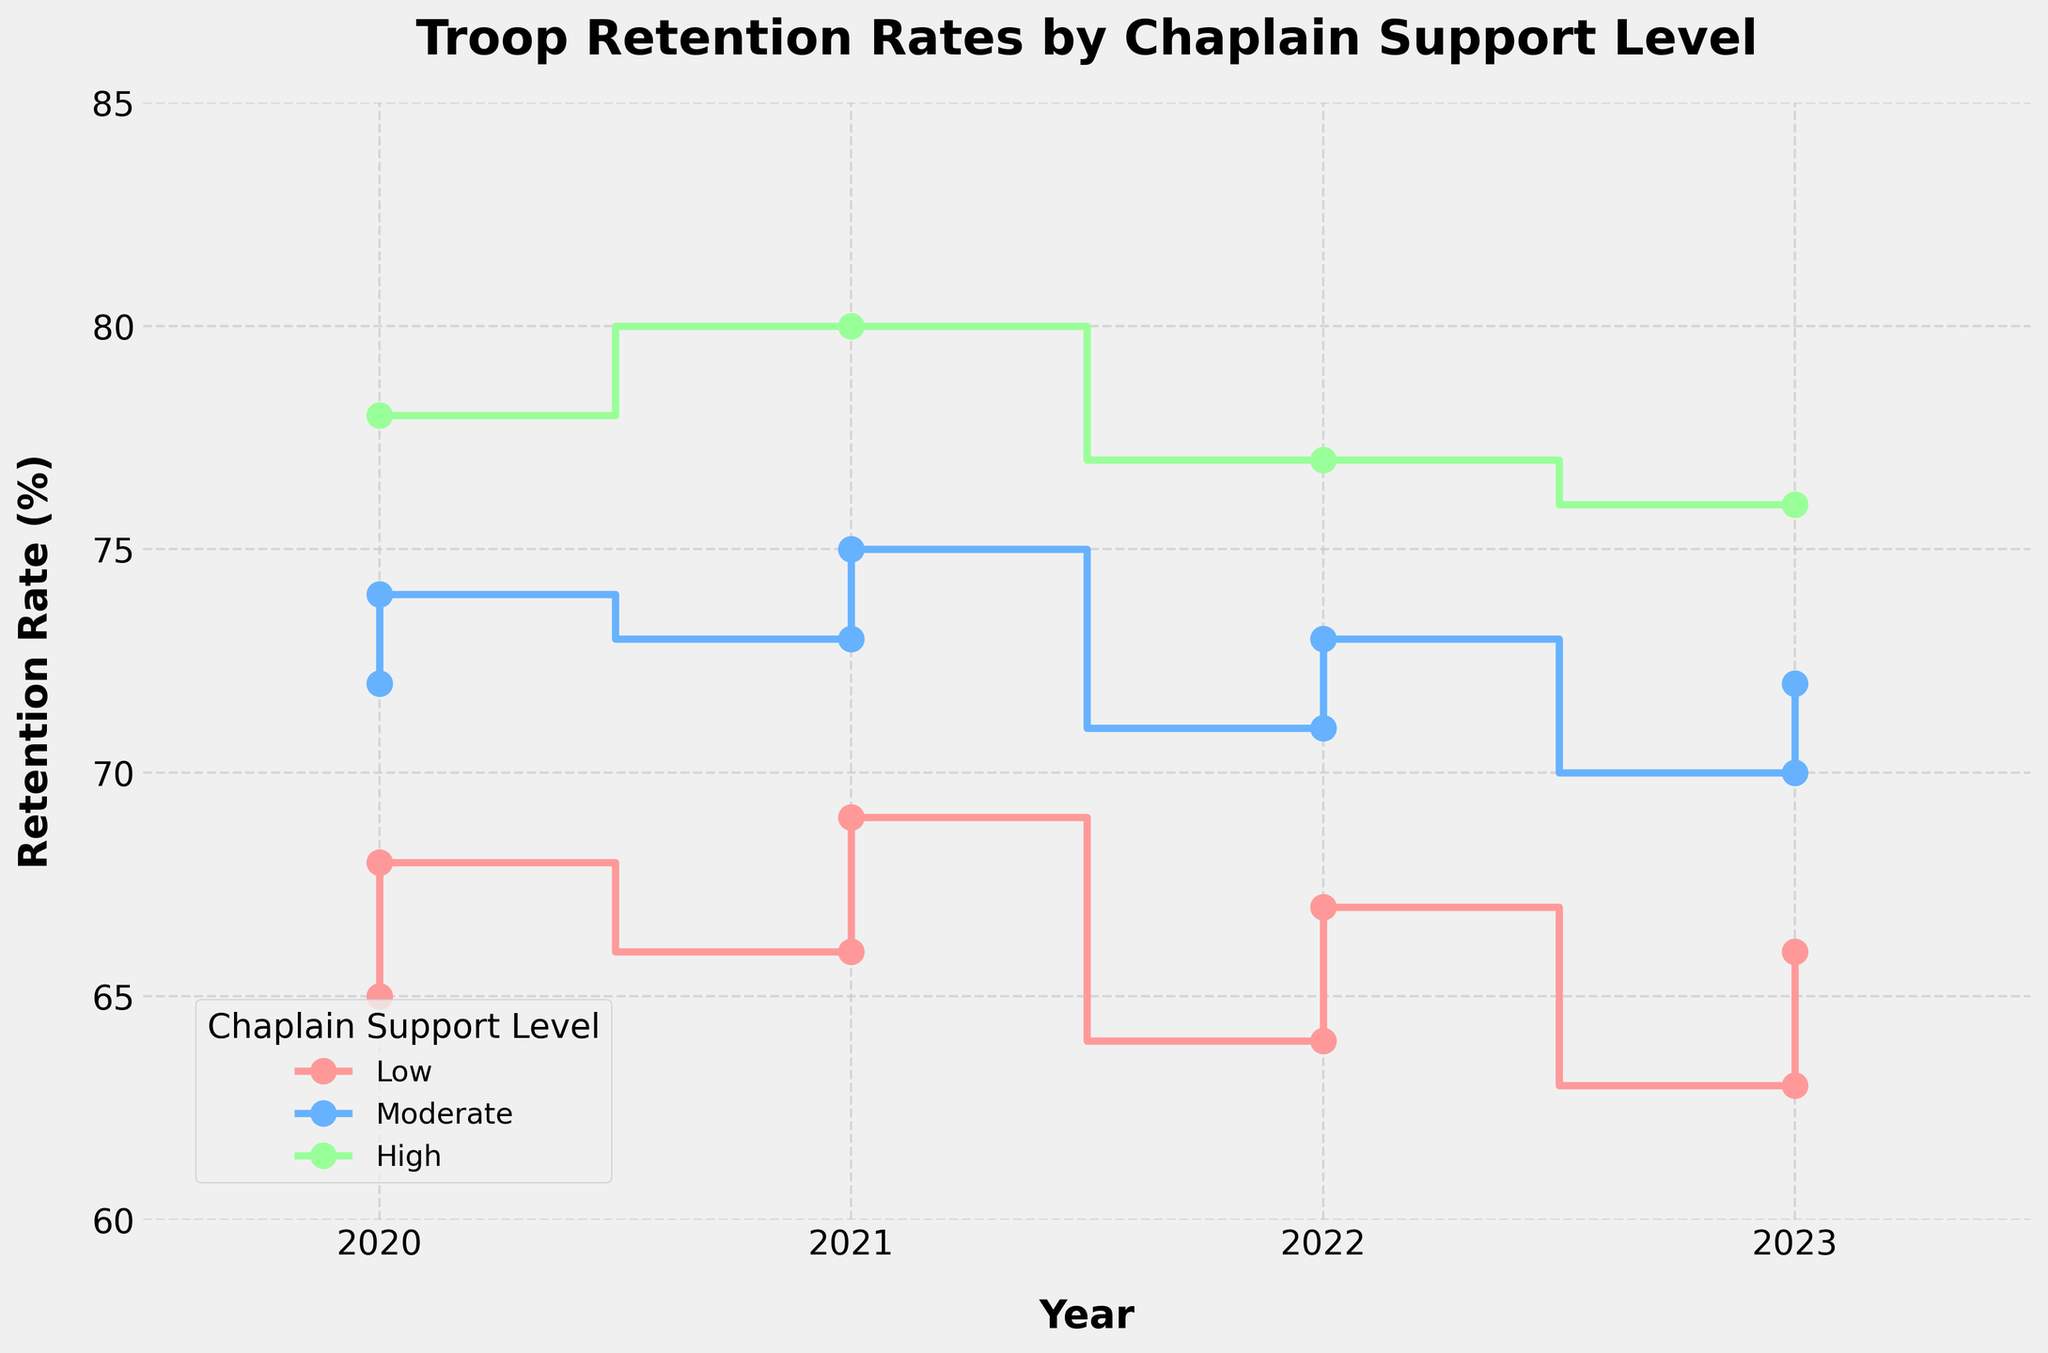What is the title of the figure? The title of the figure is displayed at the top of the plot.
Answer: Troop Retention Rates by Chaplain Support Level What is the retention rate for the 5th Aviation unit in 2023? Locate the data point for 2023 under the "High" chaplain support level line and read the retention rate.
Answer: 76% How does the retention rate for the 2nd Armored unit in 2022 compare to its rate in 2023? Find the retention rates for the 2nd Armored unit in both 2022 and 2023. Compare the two rates to see if it increased, decreased, or stayed the same.
Answer: Decreased Which chaplain support level has the highest retention rate in 2021? Identify the data points for all chaplain support levels in 2021 and determine which has the highest retention rate.
Answer: High What is the trend in retention rates for units with moderate chaplain support from 2020 to 2023? Follow the line representing the "Moderate" chaplain support level from 2020 through 2023 to observe the trend.
Answer: Decreasing Which year had the lowest overall retention rate for units with low chaplain support? Look at the "Low" chaplain support level line and identify the year at which the retention rate had its lowest point.
Answer: 2023 Calculate the average retention rate for units with high chaplain support over the years provided. Sum the retention rates for "High" chaplain support across all years and then divide by the number of years. The rates are 78, 80, 77, and 76, so (78 + 80 + 77 + 76) / 4.
Answer: 77.75 How did the retention rate for the 3rd Cavalry unit change from 2020 to 2023? Compare the retention rates for the 3rd Cavalry unit from 2020 (72%) to 2023 (70%) to determine the change.
Answer: Decreased by 2% Which chaplain support level shows the least fluctuation in retention rates over the years? Compare the range of retention rates over the years for each chaplain support level and identify the one with the smallest range.
Answer: High What can be inferred about the correlation between chaplain support levels and troop retention rates? Observe the overall trends and differences in retention rates across different chaplain support levels to infer the relationship.
Answer: Higher chaplain support levels are associated with higher retention rates 